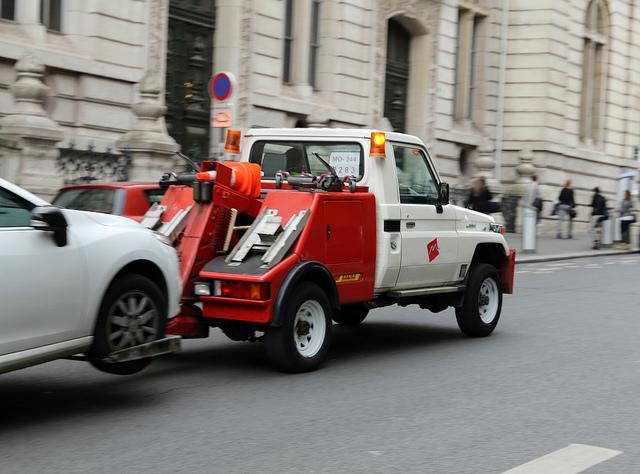How is the car on the back being propelled?

Choices:
A) oil
B) gas
C) coal engine
D) towed towed 